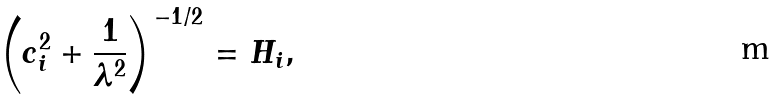<formula> <loc_0><loc_0><loc_500><loc_500>\left ( c _ { i } ^ { 2 } + \frac { 1 } { \lambda ^ { 2 } } \right ) ^ { - 1 / 2 } = H _ { i } ,</formula> 